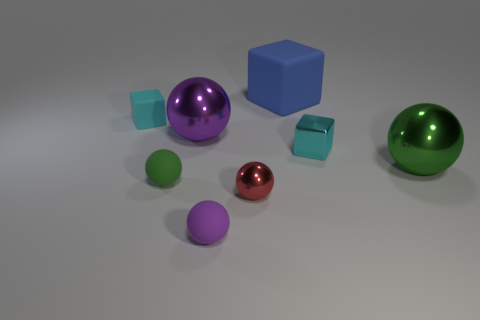How big is the cyan metallic object? Compared to the other objects in the scene, the cyan metallic cube appears to be relatively small, approximately the size of a standard die used in board games. 